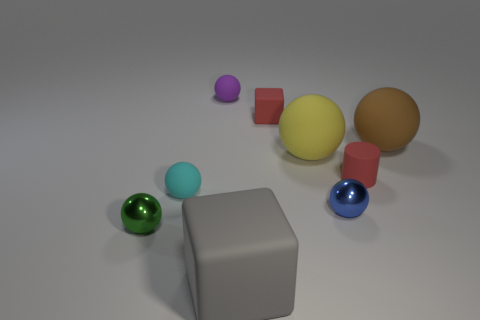Subtract 3 balls. How many balls are left? 3 Subtract all blue metal spheres. How many spheres are left? 5 Subtract all blue balls. How many balls are left? 5 Subtract all brown balls. Subtract all green cubes. How many balls are left? 5 Subtract all blocks. How many objects are left? 7 Add 3 big gray matte cylinders. How many big gray matte cylinders exist? 3 Subtract 0 green cylinders. How many objects are left? 9 Subtract all yellow things. Subtract all big yellow objects. How many objects are left? 7 Add 1 tiny cyan matte balls. How many tiny cyan matte balls are left? 2 